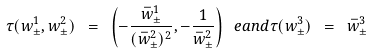Convert formula to latex. <formula><loc_0><loc_0><loc_500><loc_500>\tau ( w _ { \pm } ^ { 1 } , w _ { \pm } ^ { 2 } ) \ = \ \left ( - \frac { \bar { w } _ { \pm } ^ { 1 } } { ( \bar { w } _ { \pm } ^ { 2 } ) ^ { 2 } } , - \frac { 1 } { \bar { w } _ { \pm } ^ { 2 } } \right ) \ e a n d \tau ( w ^ { 3 } _ { \pm } ) \ = \ \bar { w } ^ { 3 } _ { \pm }</formula> 